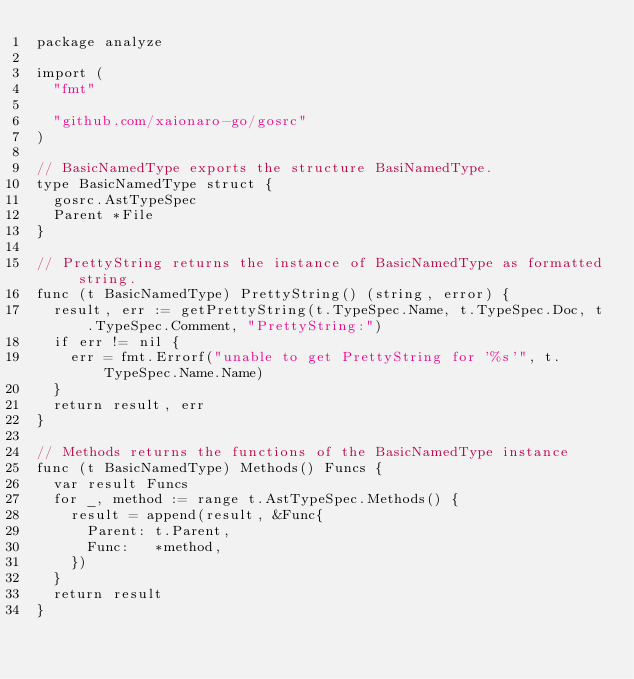<code> <loc_0><loc_0><loc_500><loc_500><_Go_>package analyze

import (
	"fmt"

	"github.com/xaionaro-go/gosrc"
)

// BasicNamedType exports the structure BasiNamedType.
type BasicNamedType struct {
	gosrc.AstTypeSpec
	Parent *File
}

// PrettyString returns the instance of BasicNamedType as formatted string.
func (t BasicNamedType) PrettyString() (string, error) {
	result, err := getPrettyString(t.TypeSpec.Name, t.TypeSpec.Doc, t.TypeSpec.Comment, "PrettyString:")
	if err != nil {
		err = fmt.Errorf("unable to get PrettyString for '%s'", t.TypeSpec.Name.Name)
	}
	return result, err
}

// Methods returns the functions of the BasicNamedType instance
func (t BasicNamedType) Methods() Funcs {
	var result Funcs
	for _, method := range t.AstTypeSpec.Methods() {
		result = append(result, &Func{
			Parent: t.Parent,
			Func:   *method,
		})
	}
	return result
}
</code> 